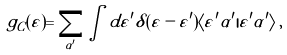Convert formula to latex. <formula><loc_0><loc_0><loc_500><loc_500>g _ { C } ( \varepsilon ) = \sum _ { \alpha ^ { \prime } } \int d \varepsilon ^ { \prime } \delta ( \varepsilon - \varepsilon ^ { \prime } ) \langle \varepsilon ^ { \prime } \alpha ^ { \prime } | \varepsilon ^ { \prime } \alpha ^ { \prime } \rangle \, ,</formula> 